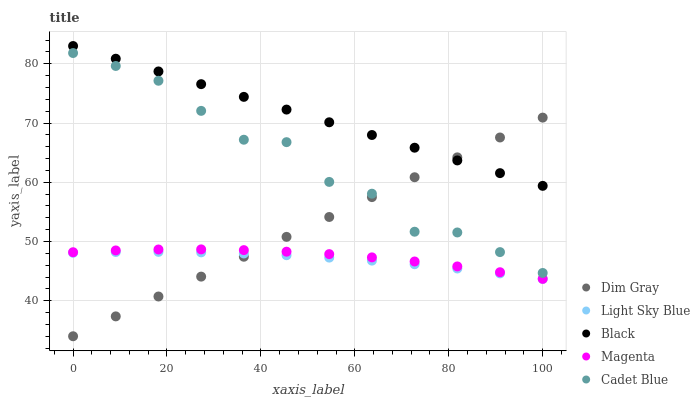Does Light Sky Blue have the minimum area under the curve?
Answer yes or no. Yes. Does Black have the maximum area under the curve?
Answer yes or no. Yes. Does Magenta have the minimum area under the curve?
Answer yes or no. No. Does Magenta have the maximum area under the curve?
Answer yes or no. No. Is Black the smoothest?
Answer yes or no. Yes. Is Cadet Blue the roughest?
Answer yes or no. Yes. Is Magenta the smoothest?
Answer yes or no. No. Is Magenta the roughest?
Answer yes or no. No. Does Dim Gray have the lowest value?
Answer yes or no. Yes. Does Magenta have the lowest value?
Answer yes or no. No. Does Black have the highest value?
Answer yes or no. Yes. Does Magenta have the highest value?
Answer yes or no. No. Is Magenta less than Cadet Blue?
Answer yes or no. Yes. Is Cadet Blue greater than Magenta?
Answer yes or no. Yes. Does Light Sky Blue intersect Dim Gray?
Answer yes or no. Yes. Is Light Sky Blue less than Dim Gray?
Answer yes or no. No. Is Light Sky Blue greater than Dim Gray?
Answer yes or no. No. Does Magenta intersect Cadet Blue?
Answer yes or no. No. 